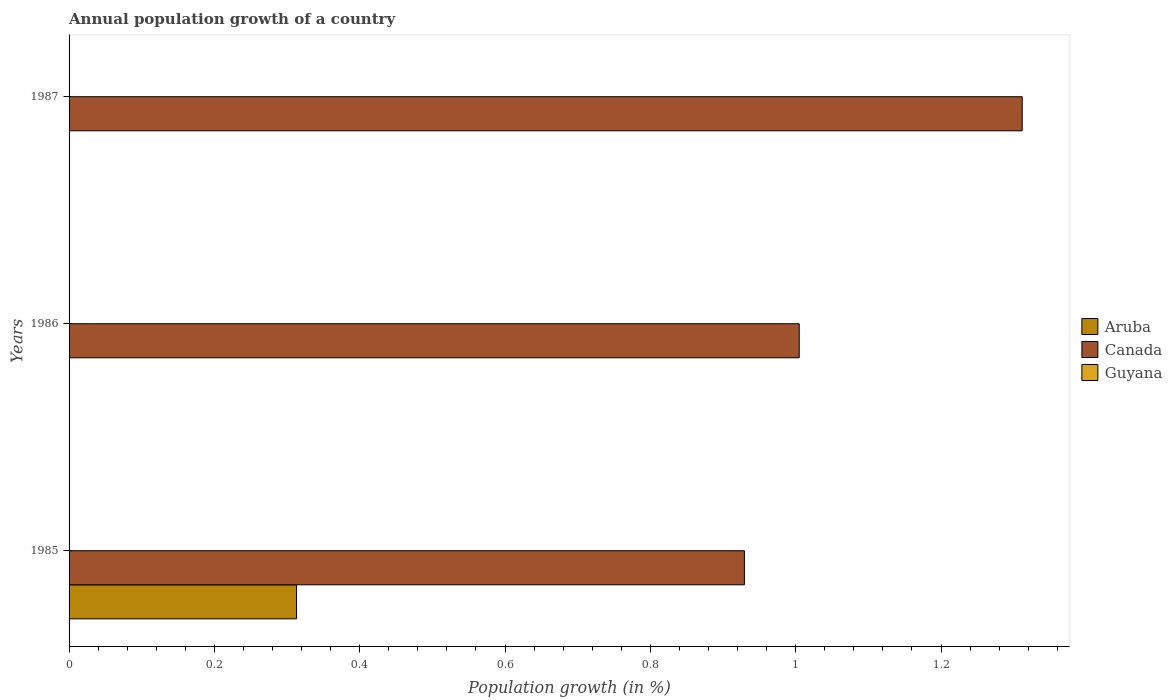How many different coloured bars are there?
Provide a short and direct response. 2. Are the number of bars per tick equal to the number of legend labels?
Your response must be concise. No. How many bars are there on the 3rd tick from the bottom?
Make the answer very short. 1. What is the label of the 2nd group of bars from the top?
Your response must be concise. 1986. In how many cases, is the number of bars for a given year not equal to the number of legend labels?
Provide a succinct answer. 3. What is the annual population growth in Aruba in 1986?
Keep it short and to the point. 0. Across all years, what is the maximum annual population growth in Canada?
Your answer should be very brief. 1.31. Across all years, what is the minimum annual population growth in Canada?
Give a very brief answer. 0.93. In which year was the annual population growth in Aruba maximum?
Your answer should be very brief. 1985. What is the total annual population growth in Guyana in the graph?
Give a very brief answer. 0. What is the difference between the annual population growth in Canada in 1985 and that in 1987?
Provide a short and direct response. -0.38. What is the difference between the annual population growth in Aruba in 1987 and the annual population growth in Guyana in 1985?
Provide a short and direct response. 0. What is the average annual population growth in Guyana per year?
Your answer should be very brief. 0. In the year 1985, what is the difference between the annual population growth in Canada and annual population growth in Aruba?
Your answer should be compact. 0.62. Is the annual population growth in Canada in 1985 less than that in 1987?
Give a very brief answer. Yes. What is the difference between the highest and the second highest annual population growth in Canada?
Your answer should be very brief. 0.31. What is the difference between the highest and the lowest annual population growth in Canada?
Your answer should be compact. 0.38. How many bars are there?
Make the answer very short. 4. Are all the bars in the graph horizontal?
Provide a succinct answer. Yes. How many years are there in the graph?
Provide a short and direct response. 3. What is the difference between two consecutive major ticks on the X-axis?
Give a very brief answer. 0.2. Are the values on the major ticks of X-axis written in scientific E-notation?
Give a very brief answer. No. Does the graph contain grids?
Offer a terse response. No. Where does the legend appear in the graph?
Keep it short and to the point. Center right. What is the title of the graph?
Give a very brief answer. Annual population growth of a country. Does "Guam" appear as one of the legend labels in the graph?
Offer a very short reply. No. What is the label or title of the X-axis?
Provide a short and direct response. Population growth (in %). What is the Population growth (in %) of Aruba in 1985?
Your answer should be very brief. 0.31. What is the Population growth (in %) of Canada in 1985?
Your answer should be very brief. 0.93. What is the Population growth (in %) of Aruba in 1986?
Offer a terse response. 0. What is the Population growth (in %) in Canada in 1986?
Make the answer very short. 1. What is the Population growth (in %) of Guyana in 1986?
Your answer should be compact. 0. What is the Population growth (in %) of Aruba in 1987?
Your answer should be compact. 0. What is the Population growth (in %) in Canada in 1987?
Provide a succinct answer. 1.31. What is the Population growth (in %) of Guyana in 1987?
Provide a succinct answer. 0. Across all years, what is the maximum Population growth (in %) of Aruba?
Provide a succinct answer. 0.31. Across all years, what is the maximum Population growth (in %) of Canada?
Your response must be concise. 1.31. Across all years, what is the minimum Population growth (in %) of Aruba?
Give a very brief answer. 0. Across all years, what is the minimum Population growth (in %) of Canada?
Make the answer very short. 0.93. What is the total Population growth (in %) in Aruba in the graph?
Your answer should be compact. 0.31. What is the total Population growth (in %) of Canada in the graph?
Your answer should be very brief. 3.25. What is the difference between the Population growth (in %) in Canada in 1985 and that in 1986?
Keep it short and to the point. -0.08. What is the difference between the Population growth (in %) in Canada in 1985 and that in 1987?
Provide a succinct answer. -0.38. What is the difference between the Population growth (in %) of Canada in 1986 and that in 1987?
Keep it short and to the point. -0.31. What is the difference between the Population growth (in %) in Aruba in 1985 and the Population growth (in %) in Canada in 1986?
Ensure brevity in your answer.  -0.69. What is the difference between the Population growth (in %) in Aruba in 1985 and the Population growth (in %) in Canada in 1987?
Offer a very short reply. -1. What is the average Population growth (in %) of Aruba per year?
Give a very brief answer. 0.1. What is the average Population growth (in %) in Canada per year?
Ensure brevity in your answer.  1.08. In the year 1985, what is the difference between the Population growth (in %) in Aruba and Population growth (in %) in Canada?
Your answer should be compact. -0.62. What is the ratio of the Population growth (in %) in Canada in 1985 to that in 1986?
Ensure brevity in your answer.  0.92. What is the ratio of the Population growth (in %) of Canada in 1985 to that in 1987?
Provide a short and direct response. 0.71. What is the ratio of the Population growth (in %) of Canada in 1986 to that in 1987?
Your response must be concise. 0.77. What is the difference between the highest and the second highest Population growth (in %) of Canada?
Offer a very short reply. 0.31. What is the difference between the highest and the lowest Population growth (in %) in Aruba?
Offer a terse response. 0.31. What is the difference between the highest and the lowest Population growth (in %) of Canada?
Offer a very short reply. 0.38. 